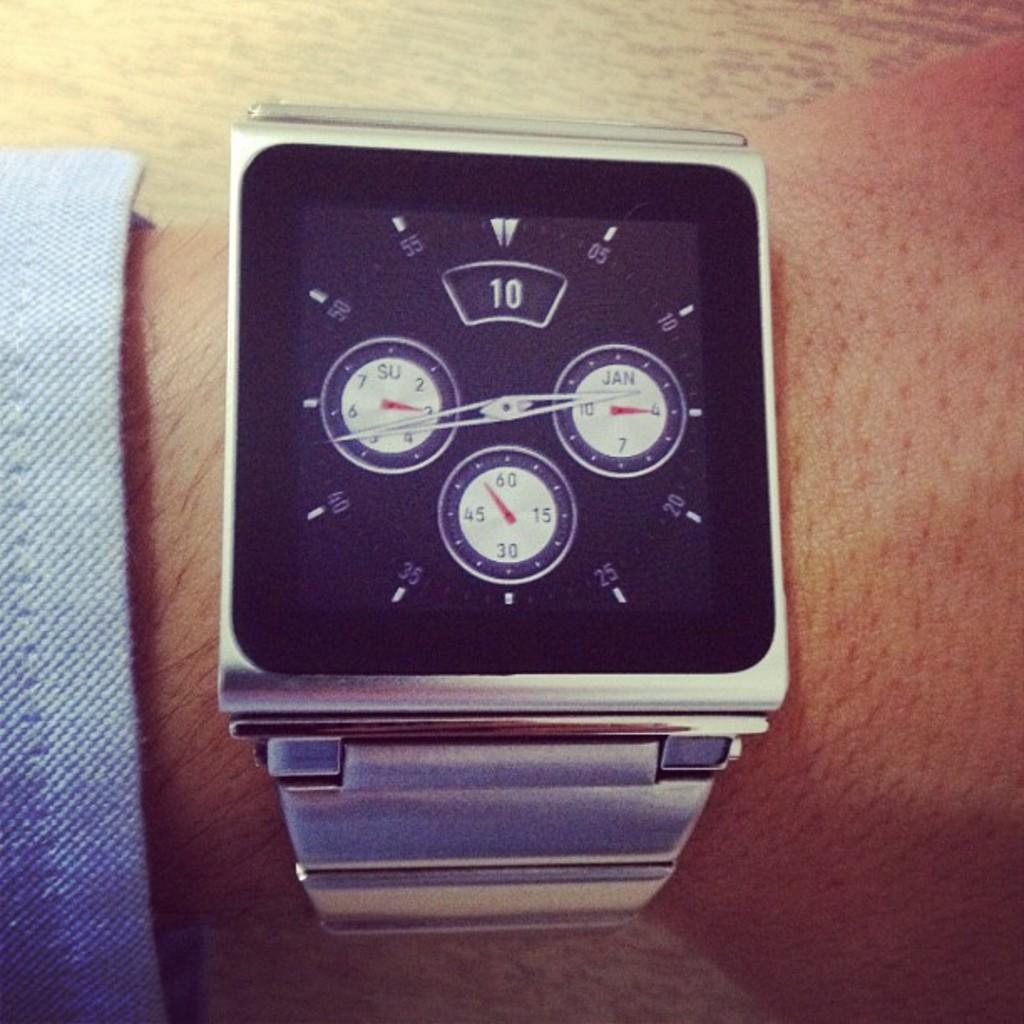What type of object is in the image? There is a silver wrist watch in the image. What is the color of the dial on the wrist watch? The wrist watch has a black dial. Is the wrist watch being worn by someone? Yes, the wrist watch is on the wrist of a person. How many circles are visible on the wrist watch? There are three circles visible on the wrist watch. What can be found inside the circles on the wrist watch? There are numbers inside the circles on the wrist watch. What type of cake is being served with a wrench in the image? There is no cake or wrench present in the image; it only features a silver wrist watch. 